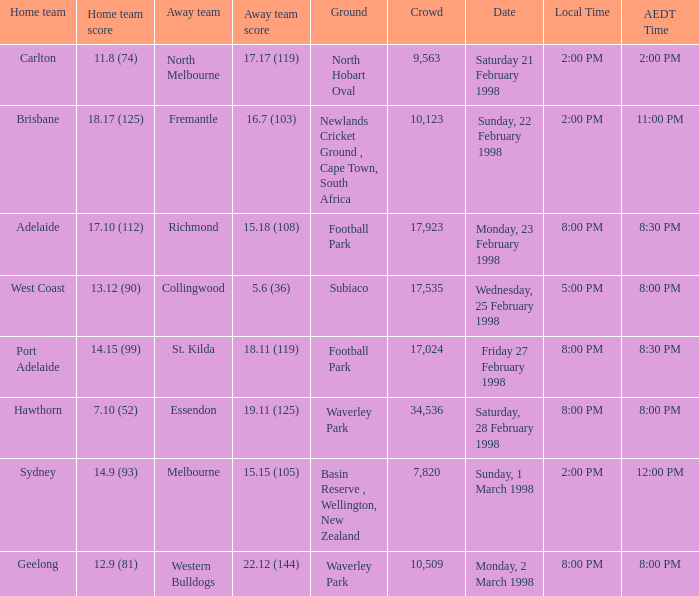Which away team has waverley park as their ground and hawthorn as their home team? Essendon. 